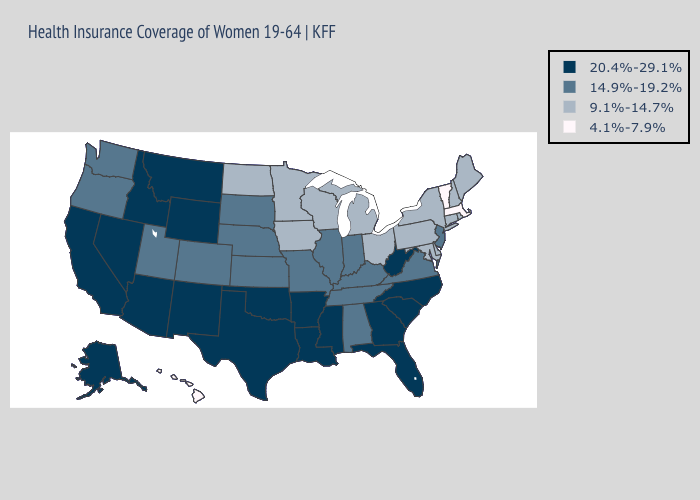What is the value of Oregon?
Quick response, please. 14.9%-19.2%. What is the highest value in the West ?
Keep it brief. 20.4%-29.1%. Name the states that have a value in the range 14.9%-19.2%?
Quick response, please. Alabama, Colorado, Illinois, Indiana, Kansas, Kentucky, Missouri, Nebraska, New Jersey, Oregon, South Dakota, Tennessee, Utah, Virginia, Washington. Name the states that have a value in the range 4.1%-7.9%?
Short answer required. Hawaii, Massachusetts, Vermont. Does Wisconsin have the highest value in the MidWest?
Answer briefly. No. Does New Jersey have a higher value than Minnesota?
Short answer required. Yes. How many symbols are there in the legend?
Give a very brief answer. 4. Among the states that border Arkansas , which have the lowest value?
Write a very short answer. Missouri, Tennessee. What is the value of Florida?
Keep it brief. 20.4%-29.1%. Which states have the lowest value in the USA?
Answer briefly. Hawaii, Massachusetts, Vermont. What is the value of Maine?
Answer briefly. 9.1%-14.7%. Name the states that have a value in the range 4.1%-7.9%?
Be succinct. Hawaii, Massachusetts, Vermont. What is the value of Missouri?
Give a very brief answer. 14.9%-19.2%. Is the legend a continuous bar?
Be succinct. No. Does Georgia have a higher value than Indiana?
Write a very short answer. Yes. 